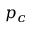Convert formula to latex. <formula><loc_0><loc_0><loc_500><loc_500>p _ { c }</formula> 